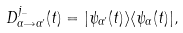<formula> <loc_0><loc_0><loc_500><loc_500>D _ { \alpha \rightarrow \alpha ^ { \prime } } ^ { j _ { - } } ( t ) = | \psi _ { \alpha ^ { \prime } } ( t ) \rangle \langle \psi _ { \alpha } ( t ) | ,</formula> 